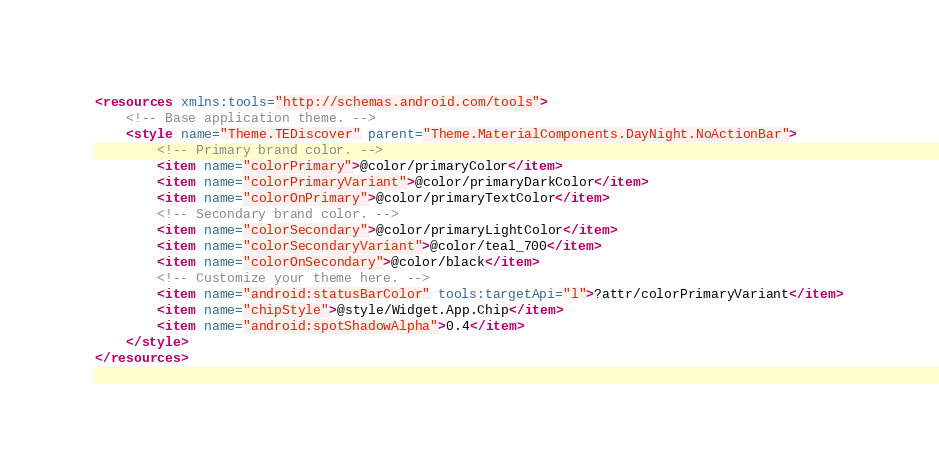<code> <loc_0><loc_0><loc_500><loc_500><_XML_><resources xmlns:tools="http://schemas.android.com/tools">
    <!-- Base application theme. -->
    <style name="Theme.TEDiscover" parent="Theme.MaterialComponents.DayNight.NoActionBar">
        <!-- Primary brand color. -->
        <item name="colorPrimary">@color/primaryColor</item>
        <item name="colorPrimaryVariant">@color/primaryDarkColor</item>
        <item name="colorOnPrimary">@color/primaryTextColor</item>
        <!-- Secondary brand color. -->
        <item name="colorSecondary">@color/primaryLightColor</item>
        <item name="colorSecondaryVariant">@color/teal_700</item>
        <item name="colorOnSecondary">@color/black</item>
        <!-- Customize your theme here. -->
        <item name="android:statusBarColor" tools:targetApi="l">?attr/colorPrimaryVariant</item>
        <item name="chipStyle">@style/Widget.App.Chip</item>
        <item name="android:spotShadowAlpha">0.4</item>
    </style>
</resources></code> 